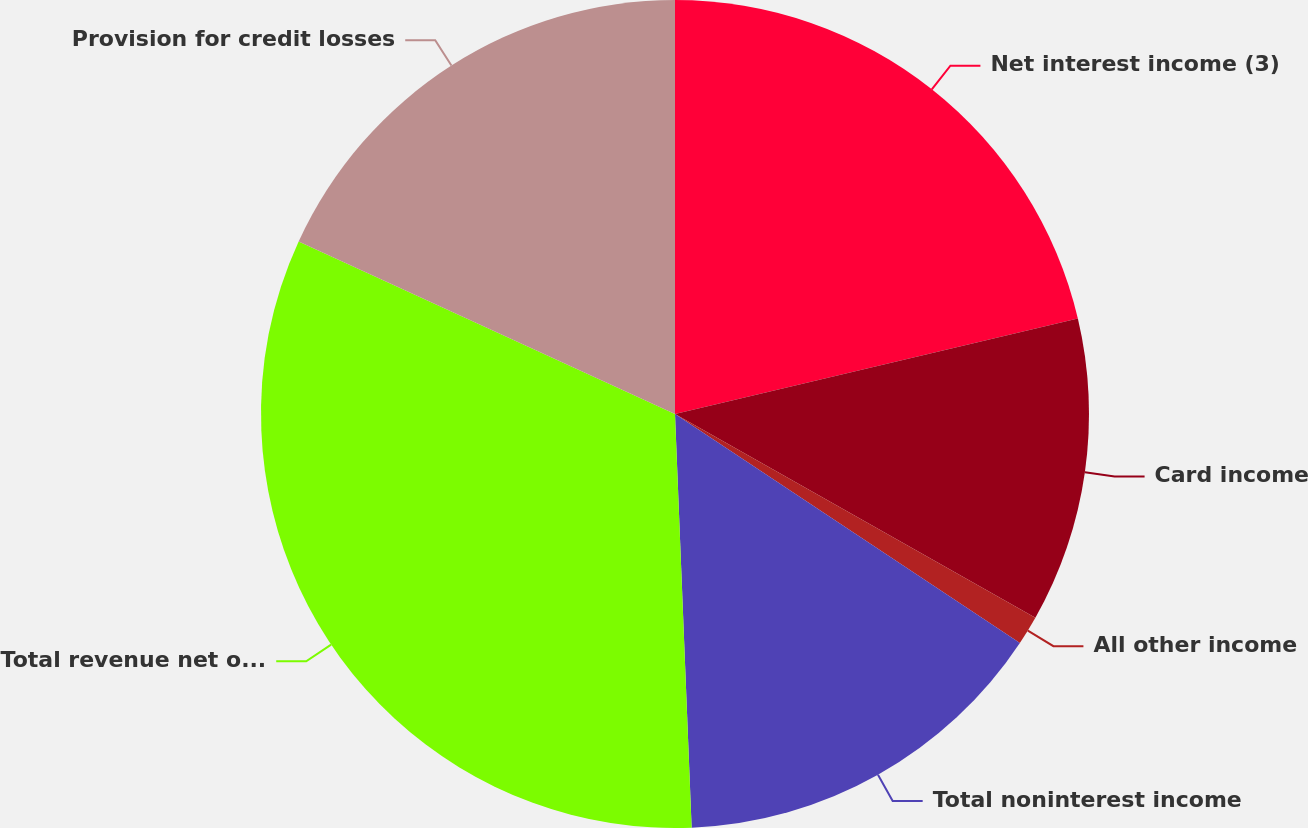Convert chart. <chart><loc_0><loc_0><loc_500><loc_500><pie_chart><fcel>Net interest income (3)<fcel>Card income<fcel>All other income<fcel>Total noninterest income<fcel>Total revenue net of interest<fcel>Provision for credit losses<nl><fcel>21.3%<fcel>11.89%<fcel>1.14%<fcel>15.03%<fcel>32.48%<fcel>18.16%<nl></chart> 